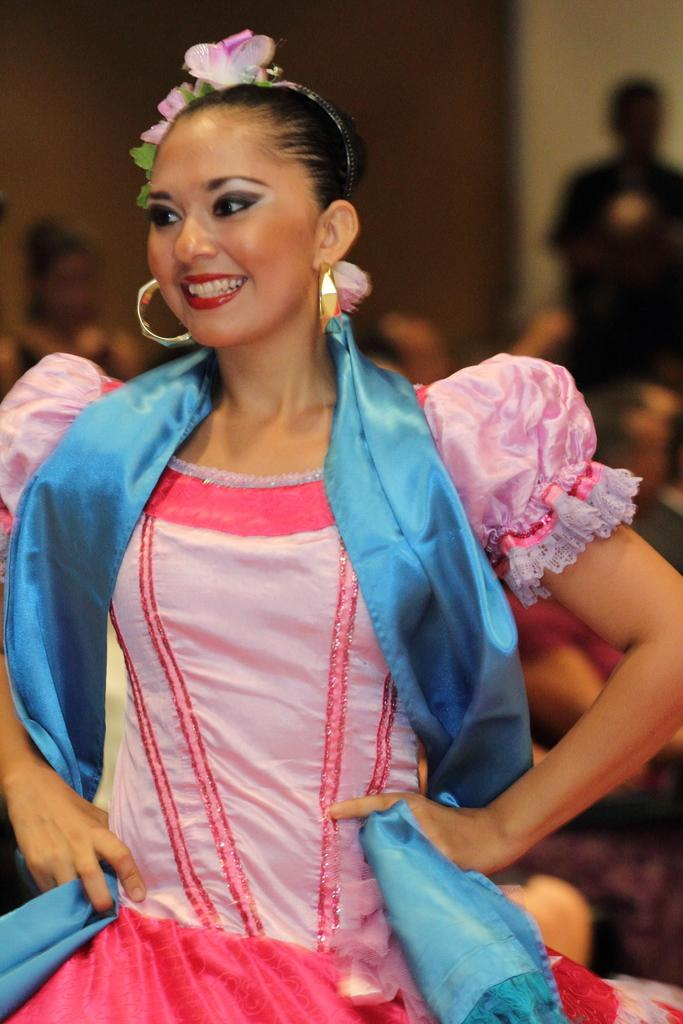What is the main subject in the foreground of the picture? There is a woman in the foreground of the picture. What is the woman wearing? The woman is wearing a pink dress. What is the woman's facial expression? The woman is smiling. What can be seen in the background of the picture? There are persons and a wall in the background of the picture. How many brothers does the woman have in the picture? There is no information about the woman's brothers in the image. What type of passenger is the woman in the picture? The image does not depict any form of transportation, so there is no passenger in the picture. 